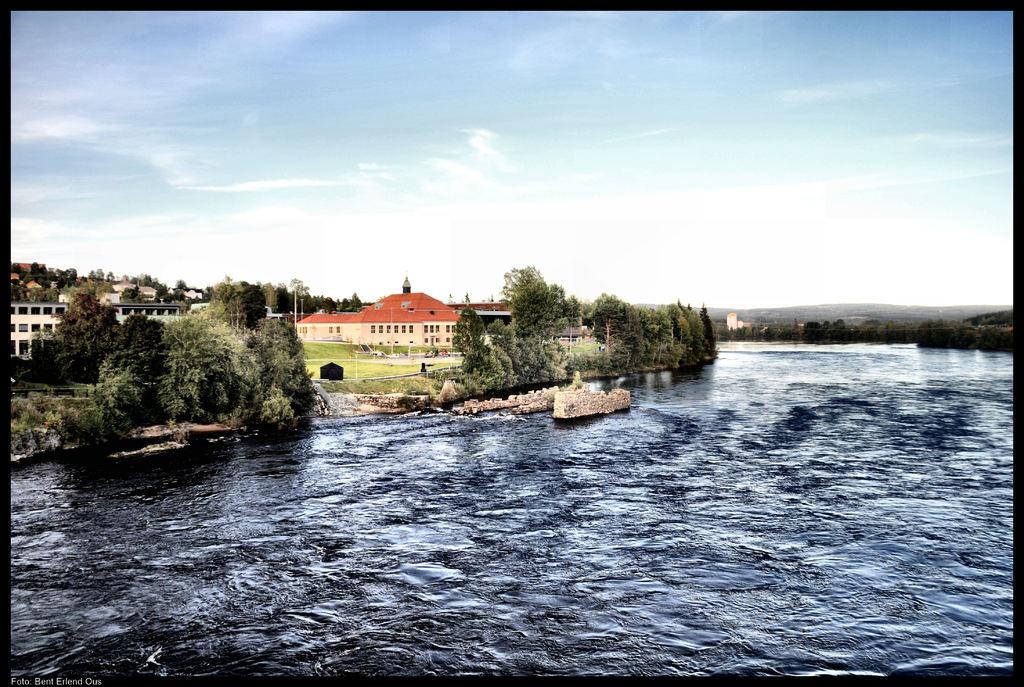What is the primary element visible in the image? There is water in the image. What type of vegetation is present near the water? There are trees on the sides of the water. What type of structures can be seen in the image? There are buildings in the image. What is visible in the background of the image? The sky is visible in the background of the image. What type of organization is depicted in the image? There is no organization depicted in the image; it features water, trees, buildings, and the sky. What part of the human body can be seen in the image? There are no human body parts present in the image. 